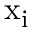Convert formula to latex. <formula><loc_0><loc_0><loc_500><loc_500>{ x } _ { i }</formula> 